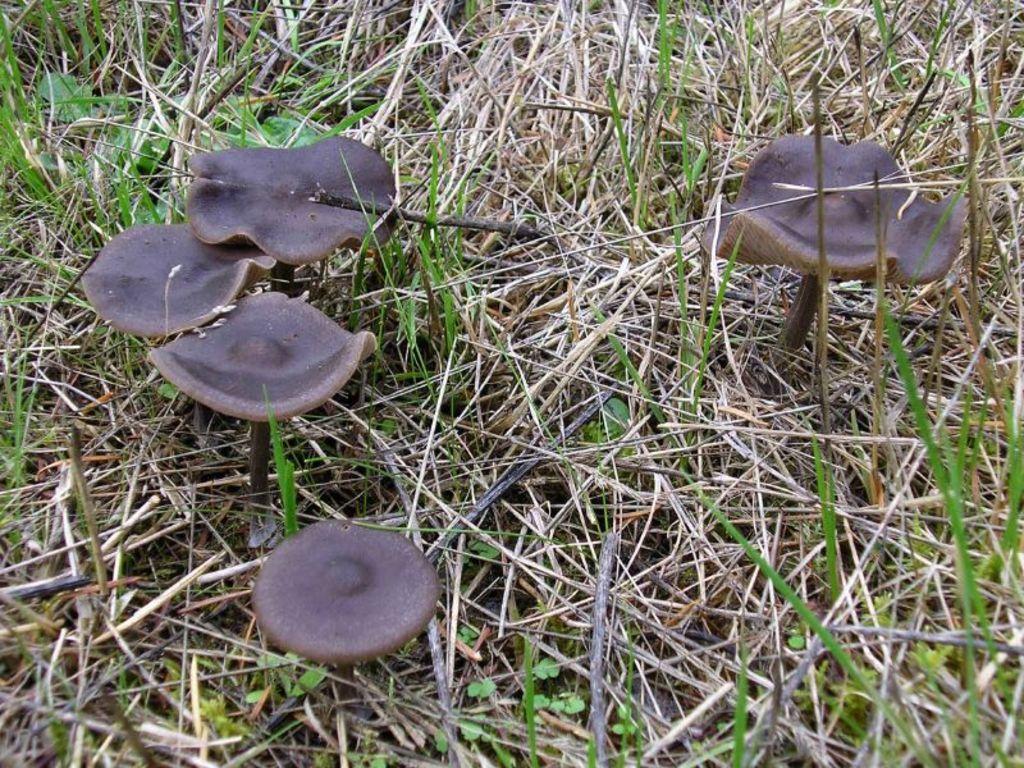Could you give a brief overview of what you see in this image? In this image we can see few mushrooms. Around the mushrooms we can see the grass. 